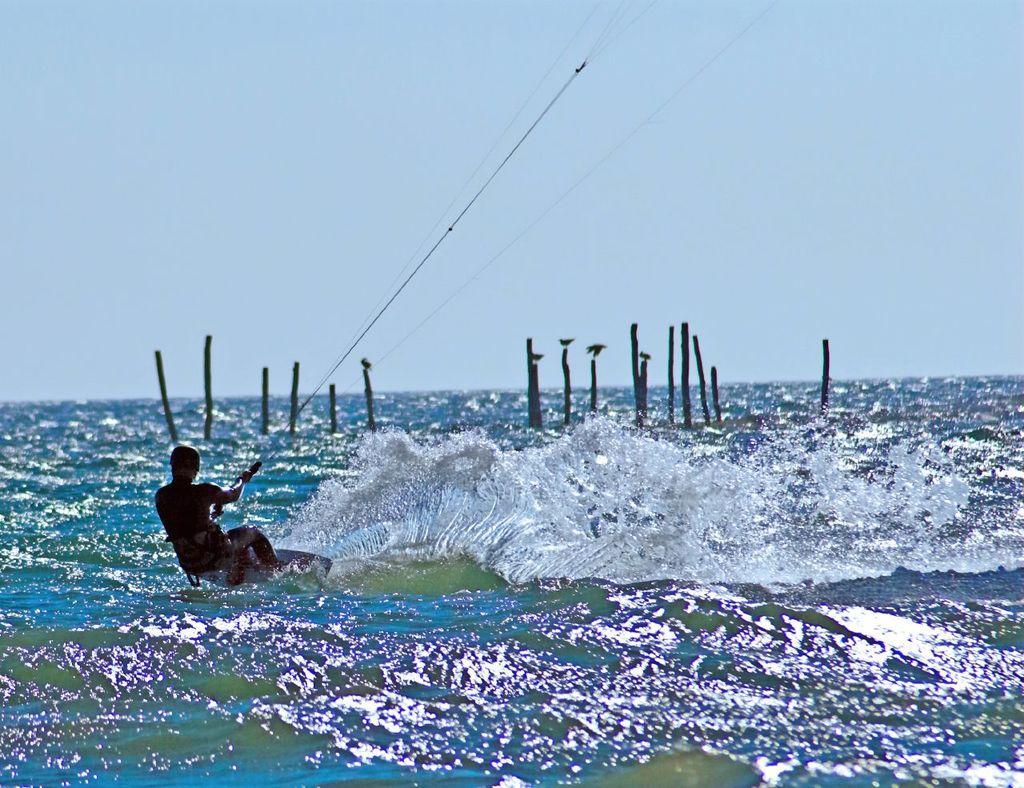In one or two sentences, can you explain what this image depicts? To the bottom of the image there is water. In the water there is a man with a surfboard. He is holding the rope with his hands. And in the middle of the water there are stick poles. 